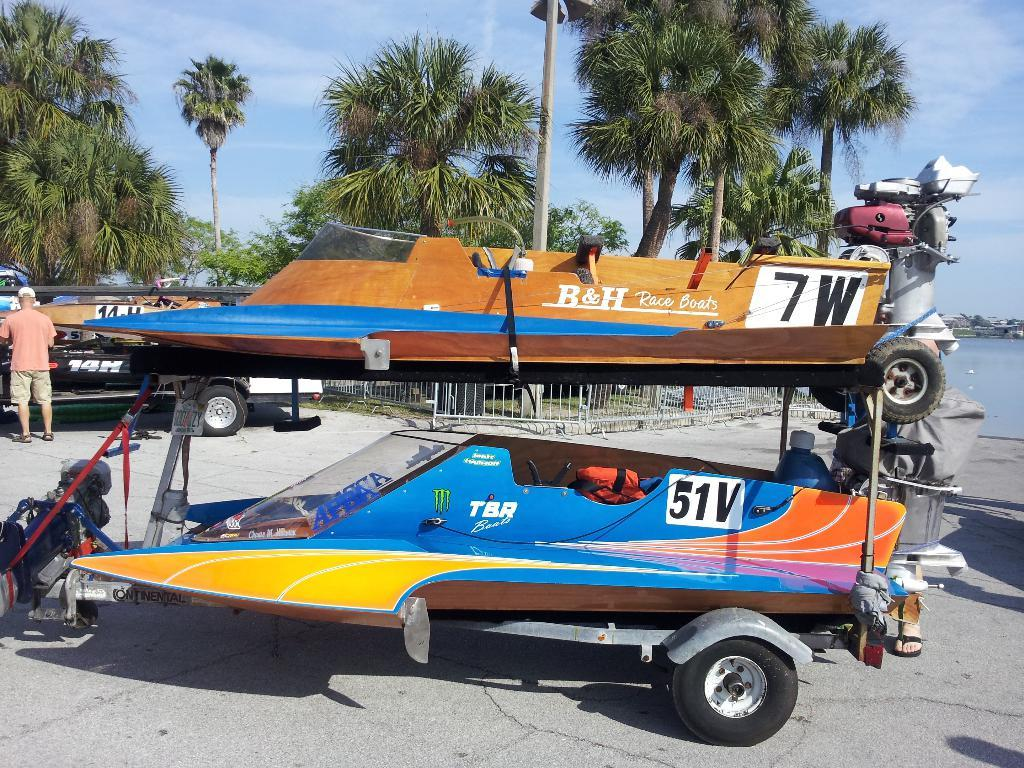<image>
Summarize the visual content of the image. A little boat has 7W written on the back of it. 